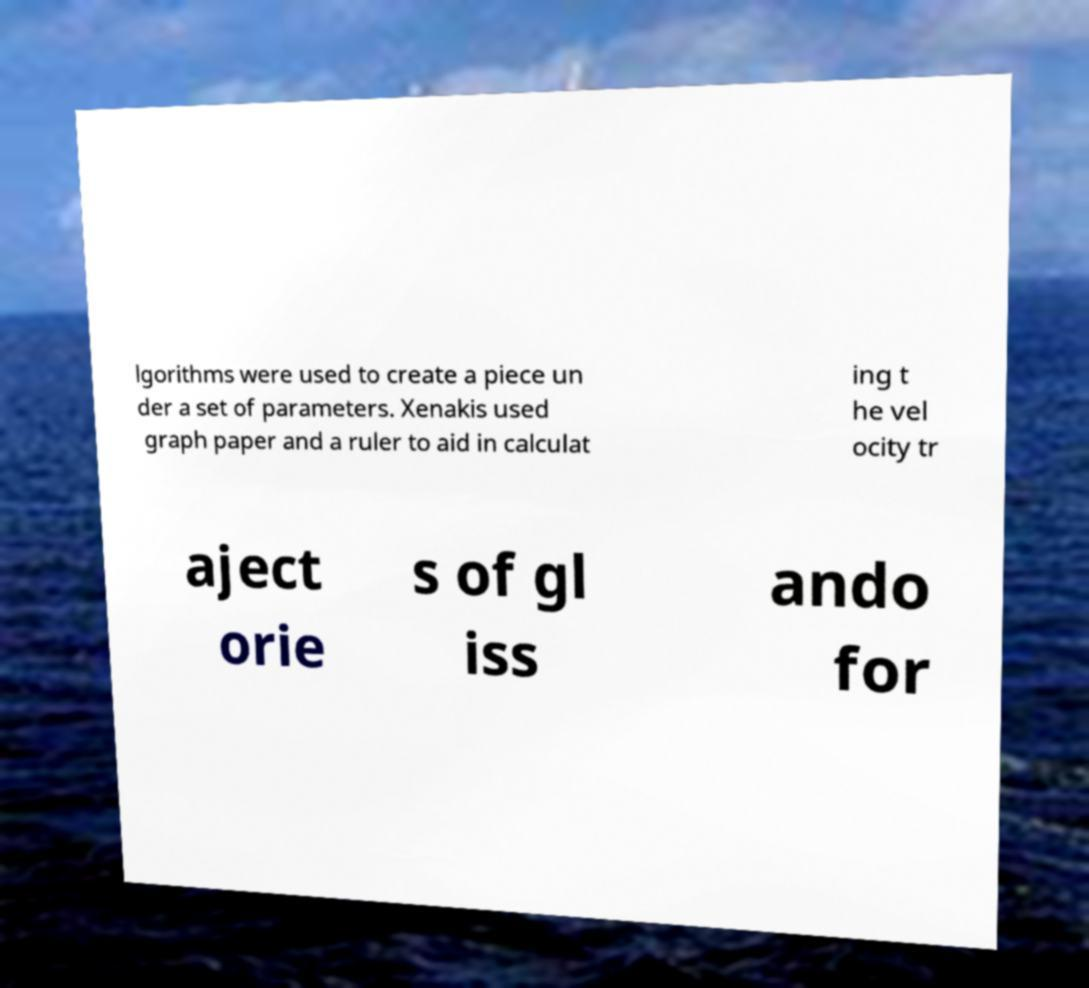Could you extract and type out the text from this image? lgorithms were used to create a piece un der a set of parameters. Xenakis used graph paper and a ruler to aid in calculat ing t he vel ocity tr aject orie s of gl iss ando for 